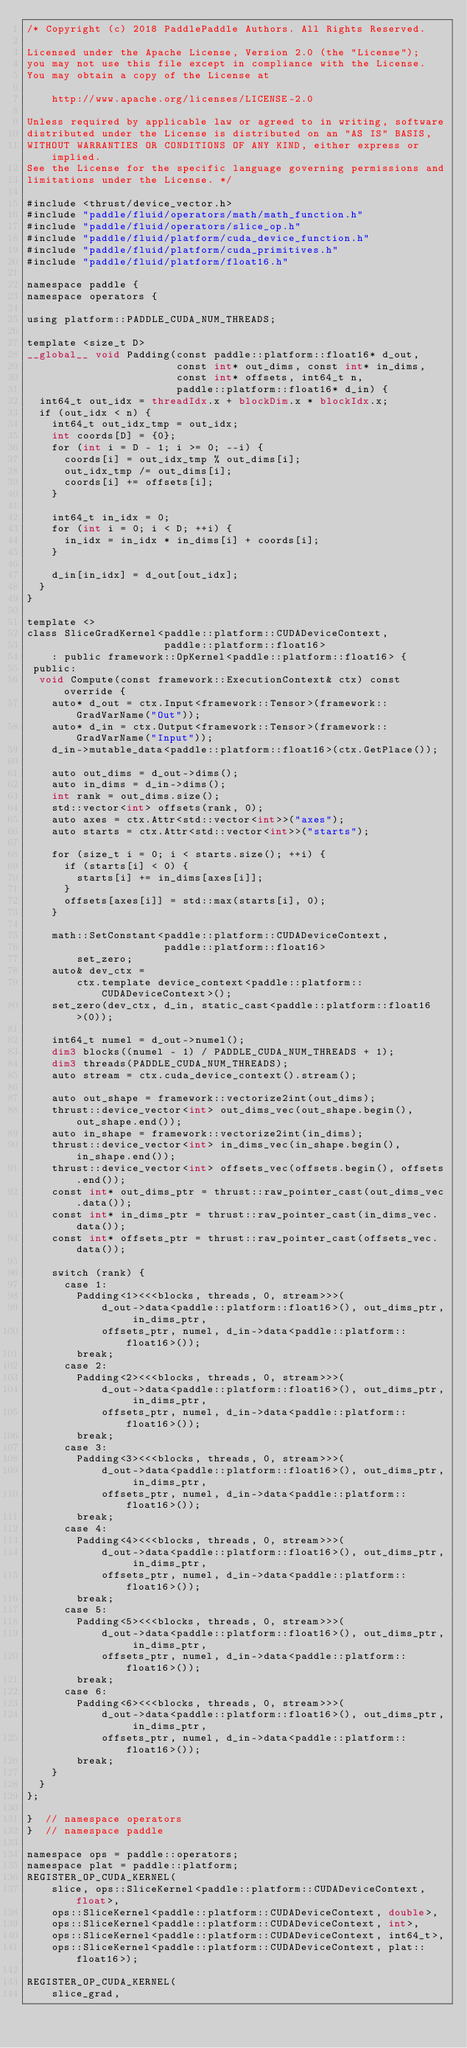<code> <loc_0><loc_0><loc_500><loc_500><_Cuda_>/* Copyright (c) 2018 PaddlePaddle Authors. All Rights Reserved.

Licensed under the Apache License, Version 2.0 (the "License");
you may not use this file except in compliance with the License.
You may obtain a copy of the License at

    http://www.apache.org/licenses/LICENSE-2.0

Unless required by applicable law or agreed to in writing, software
distributed under the License is distributed on an "AS IS" BASIS,
WITHOUT WARRANTIES OR CONDITIONS OF ANY KIND, either express or implied.
See the License for the specific language governing permissions and
limitations under the License. */

#include <thrust/device_vector.h>
#include "paddle/fluid/operators/math/math_function.h"
#include "paddle/fluid/operators/slice_op.h"
#include "paddle/fluid/platform/cuda_device_function.h"
#include "paddle/fluid/platform/cuda_primitives.h"
#include "paddle/fluid/platform/float16.h"

namespace paddle {
namespace operators {

using platform::PADDLE_CUDA_NUM_THREADS;

template <size_t D>
__global__ void Padding(const paddle::platform::float16* d_out,
                        const int* out_dims, const int* in_dims,
                        const int* offsets, int64_t n,
                        paddle::platform::float16* d_in) {
  int64_t out_idx = threadIdx.x + blockDim.x * blockIdx.x;
  if (out_idx < n) {
    int64_t out_idx_tmp = out_idx;
    int coords[D] = {0};
    for (int i = D - 1; i >= 0; --i) {
      coords[i] = out_idx_tmp % out_dims[i];
      out_idx_tmp /= out_dims[i];
      coords[i] += offsets[i];
    }

    int64_t in_idx = 0;
    for (int i = 0; i < D; ++i) {
      in_idx = in_idx * in_dims[i] + coords[i];
    }

    d_in[in_idx] = d_out[out_idx];
  }
}

template <>
class SliceGradKernel<paddle::platform::CUDADeviceContext,
                      paddle::platform::float16>
    : public framework::OpKernel<paddle::platform::float16> {
 public:
  void Compute(const framework::ExecutionContext& ctx) const override {
    auto* d_out = ctx.Input<framework::Tensor>(framework::GradVarName("Out"));
    auto* d_in = ctx.Output<framework::Tensor>(framework::GradVarName("Input"));
    d_in->mutable_data<paddle::platform::float16>(ctx.GetPlace());

    auto out_dims = d_out->dims();
    auto in_dims = d_in->dims();
    int rank = out_dims.size();
    std::vector<int> offsets(rank, 0);
    auto axes = ctx.Attr<std::vector<int>>("axes");
    auto starts = ctx.Attr<std::vector<int>>("starts");

    for (size_t i = 0; i < starts.size(); ++i) {
      if (starts[i] < 0) {
        starts[i] += in_dims[axes[i]];
      }
      offsets[axes[i]] = std::max(starts[i], 0);
    }

    math::SetConstant<paddle::platform::CUDADeviceContext,
                      paddle::platform::float16>
        set_zero;
    auto& dev_ctx =
        ctx.template device_context<paddle::platform::CUDADeviceContext>();
    set_zero(dev_ctx, d_in, static_cast<paddle::platform::float16>(0));

    int64_t numel = d_out->numel();
    dim3 blocks((numel - 1) / PADDLE_CUDA_NUM_THREADS + 1);
    dim3 threads(PADDLE_CUDA_NUM_THREADS);
    auto stream = ctx.cuda_device_context().stream();

    auto out_shape = framework::vectorize2int(out_dims);
    thrust::device_vector<int> out_dims_vec(out_shape.begin(), out_shape.end());
    auto in_shape = framework::vectorize2int(in_dims);
    thrust::device_vector<int> in_dims_vec(in_shape.begin(), in_shape.end());
    thrust::device_vector<int> offsets_vec(offsets.begin(), offsets.end());
    const int* out_dims_ptr = thrust::raw_pointer_cast(out_dims_vec.data());
    const int* in_dims_ptr = thrust::raw_pointer_cast(in_dims_vec.data());
    const int* offsets_ptr = thrust::raw_pointer_cast(offsets_vec.data());

    switch (rank) {
      case 1:
        Padding<1><<<blocks, threads, 0, stream>>>(
            d_out->data<paddle::platform::float16>(), out_dims_ptr, in_dims_ptr,
            offsets_ptr, numel, d_in->data<paddle::platform::float16>());
        break;
      case 2:
        Padding<2><<<blocks, threads, 0, stream>>>(
            d_out->data<paddle::platform::float16>(), out_dims_ptr, in_dims_ptr,
            offsets_ptr, numel, d_in->data<paddle::platform::float16>());
        break;
      case 3:
        Padding<3><<<blocks, threads, 0, stream>>>(
            d_out->data<paddle::platform::float16>(), out_dims_ptr, in_dims_ptr,
            offsets_ptr, numel, d_in->data<paddle::platform::float16>());
        break;
      case 4:
        Padding<4><<<blocks, threads, 0, stream>>>(
            d_out->data<paddle::platform::float16>(), out_dims_ptr, in_dims_ptr,
            offsets_ptr, numel, d_in->data<paddle::platform::float16>());
        break;
      case 5:
        Padding<5><<<blocks, threads, 0, stream>>>(
            d_out->data<paddle::platform::float16>(), out_dims_ptr, in_dims_ptr,
            offsets_ptr, numel, d_in->data<paddle::platform::float16>());
        break;
      case 6:
        Padding<6><<<blocks, threads, 0, stream>>>(
            d_out->data<paddle::platform::float16>(), out_dims_ptr, in_dims_ptr,
            offsets_ptr, numel, d_in->data<paddle::platform::float16>());
        break;
    }
  }
};

}  // namespace operators
}  // namespace paddle

namespace ops = paddle::operators;
namespace plat = paddle::platform;
REGISTER_OP_CUDA_KERNEL(
    slice, ops::SliceKernel<paddle::platform::CUDADeviceContext, float>,
    ops::SliceKernel<paddle::platform::CUDADeviceContext, double>,
    ops::SliceKernel<paddle::platform::CUDADeviceContext, int>,
    ops::SliceKernel<paddle::platform::CUDADeviceContext, int64_t>,
    ops::SliceKernel<paddle::platform::CUDADeviceContext, plat::float16>);

REGISTER_OP_CUDA_KERNEL(
    slice_grad,</code> 